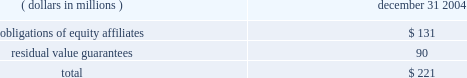Guarantees in november 2002 , the fasb issued interpretation no .
45 ( 201cfin 45 201d ) , 201cguarantor 2019s accounting and disclosure requirements for guarantees , including indirect guarantees of indebtedness of others , 201d an interpretation of fasb statements no .
5 , 57 , and 107 and rescission of fasb interpretation no .
34 .
Fin 45 clarifies the requirements of sfas no .
5 , 201caccounting for contingencies , 201d relating to the guarantor 2019s accounting for , and disclosure of , the issuance of certain types of guarantees .
Disclosures about each group of similar guarantees are provided below and summarized in the table: .
If certain operating leases are terminated by the company , it guarantees a portion of the residual value loss , if any , incurred by the lessors in disposing of the related assets .
Under these operating leases , the residual value guarantees at december 31 , 2004 totaled $ 90 million and consisted primarily of leases for railcars , company aircraft , and other equipment .
The company believes , based on current facts and circumstances , that a material payment pursuant to such guarantees is remote .
Guarantees and claims also arise during the ordinary course of business from relationships with suppliers , customers and non-consolidated affiliates when the company undertakes an obligation to guarantee the performance of others if specified triggering events occur .
Non-performance under a contract could trigger an obligation of the company .
These potential claims include actions based upon alleged exposures to products , intellectual property and environmental matters , and other indemnifications .
The ultimate effect on future financial results is not subject to reasonable estimation because considerable uncertainty exists as to the final outcome of these claims .
However , while the ultimate liabilities resulting from such claims may be significant to results of operations in the period recognized , management does not anticipate they will have a material adverse effect on the company 2019s consolidated financial position or liquidity .
Product warranty liability the company warrants to the original purchaser of its products that it will repair or replace without charge products if they fail due to a manufacturing defect .
However , the company 2019s historical claims experience has not been material .
The estimated product warranty liability for the company 2019s products as of december 31 , 2004 is approximately $ 1 million .
The company accrues for product warranties when it is probable that customers will make claims under warranties relating to products that have been sold and a reasonable estimate of the costs can be made .
Variable interest entities the company has evaluated material relationships including the guarantees related to the third-party borrowings of joint ventures described above and has concluded that the entities are not variable interest entities ( 201cvies 201d ) or , in the case of primester , a joint venture that manufactures cellulose acetate at its kingsport , tennessee plant , the company is not the primary beneficiary of the vie .
As such , in accordance with fin 46r , the company is not required to consolidate these entities .
In addition , the company has evaluated long-term purchase obligations with two entities that may be vies at december 31 , 2004 .
These potential vies are joint ventures from which the company has purchased raw materials and utilities for several years and purchases approximately $ 40 million of raw materials and utilities on an annual basis .
The company has no equity interest in these entities and has confirmed that one party to each of these joint ventures does consolidate the potential vie .
However , due to competitive and other reasons , the company has not been able to obtain the necessary financial information to determine whether the entities are vies , and if one or both are vies , whether or not the company is the primary beneficiary .
Notes to consolidated financial statements eastman chemical company and subsidiaries 2013 80 2013 .
In 2004 what was the ratio of the obligations of equity affiliates to residual value guarantees? 
Computations: (131 / 90)
Answer: 1.45556. 